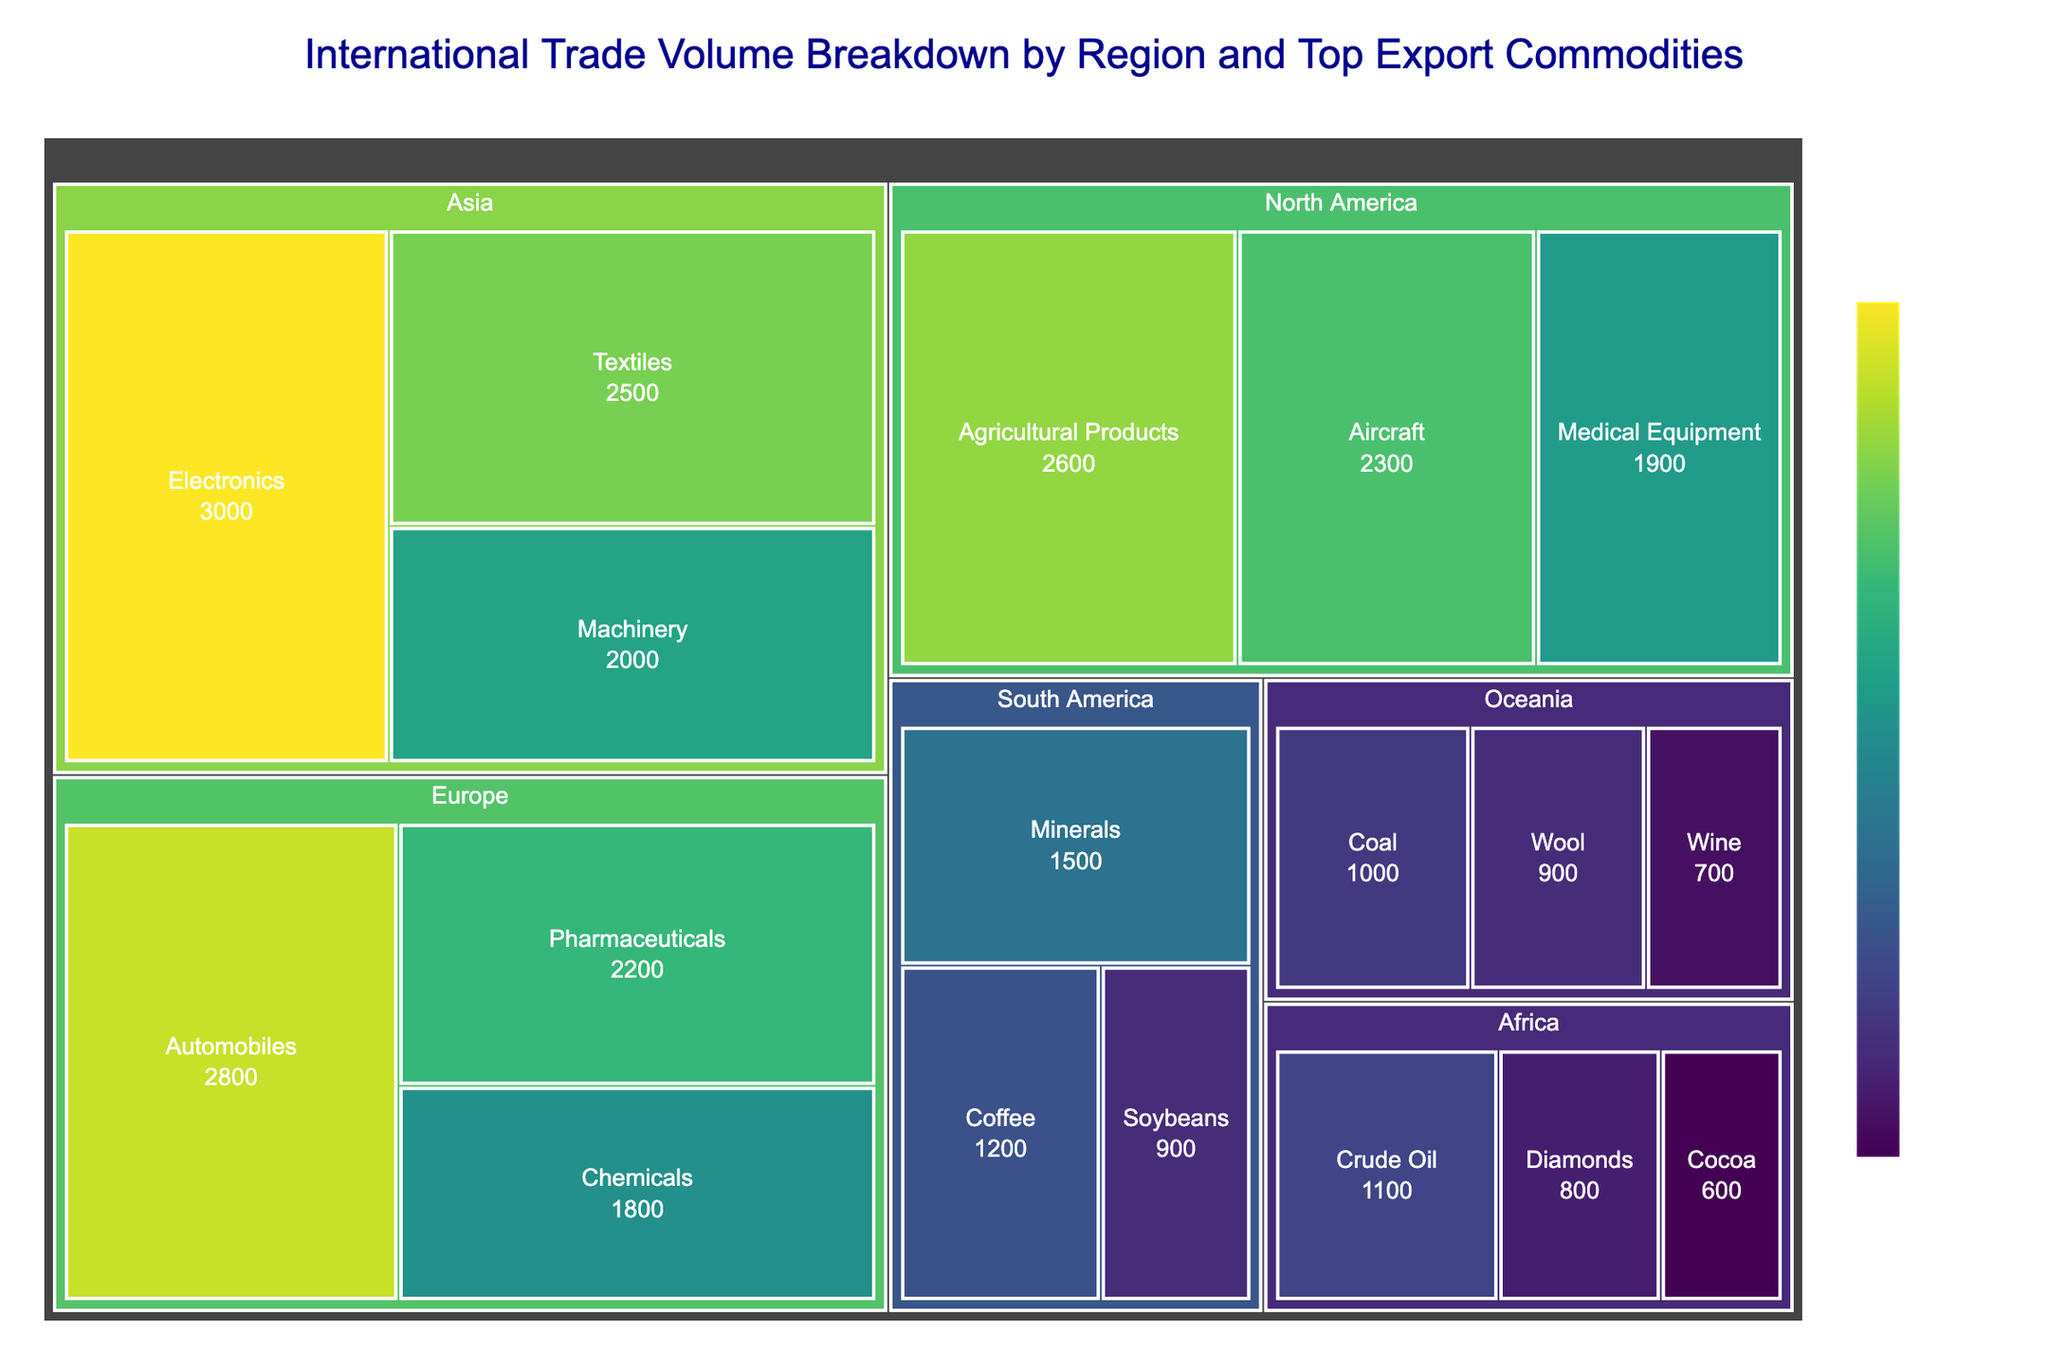How is the export value breakdown visually represented? The export values are represented using a treemap where each region and its top export commodities are displayed as rectangular tiles. Larger rectangles indicate higher export values, and the colors vary to show different value ranges.
Answer: Treemap with colored rectangular tiles Which region has the highest total export value? By observing the treemap, Asia has the largest visible combined area for its export commodities, representing the highest total export value.
Answer: Asia What are the top export commodities from North America? From the treemap, the top export commodities from North America are Agricultural Products, Aircraft, and Medical Equipment.
Answer: Agricultural Products, Aircraft, and Medical Equipment What's the total export value of European regions and how do you calculate it? Sum the individual export values of Automobiles ($2800 million), Pharmaceuticals ($2200 million), and Chemicals ($1800 million). This yields a total of $6800 million.
Answer: $6800 million Which commodity has the lowest export value globally? Checking the smallest rectangles, **Africa’s Cocoa** has the lowest export value of $600 million.
Answer: Cocoa Which two regions combined have similar total export values to Europe? Comparing Europe’s total export value ($6800 million), combine North America ($6800 million) and South America’s ($3600 million) values for a close total of $6400 million.
Answer: North America and South America How does the export value of Medical Equipment in North America compare to Cocoa in Africa? Medical Equipment in North America is $1900 million, while Cocoa in Africa is $600 million. Since $1900 million is significantly larger, Medical Equipment has a higher export value than Cocoa.
Answer: Medical Equipment is higher What’s the range of export values in the treemap? The highest export value is Asia’s Electronics at $3000 million and the lowest is Africa’s Cocoa at $600 million, making the range from $600 million to $3000 million.
Answer: $600 million to $3000 million What is the average export value of commodities in Oceania? Sum all Oceania’s top export commodity values: Coal ($1000 million), Wool ($900 million), and Wine ($700 million). This results in $2600 million. Divide s $2600 by 3, equals approximately $867 million.
Answer: Approximately $867 million Which region has a higher export value for Diamonds—Africa or South America? From the treemap, we see Africa's export value of Diamonds is $800 million. South America does not have Diamonds listed, meaning Africa has the higher value.
Answer: Africa 